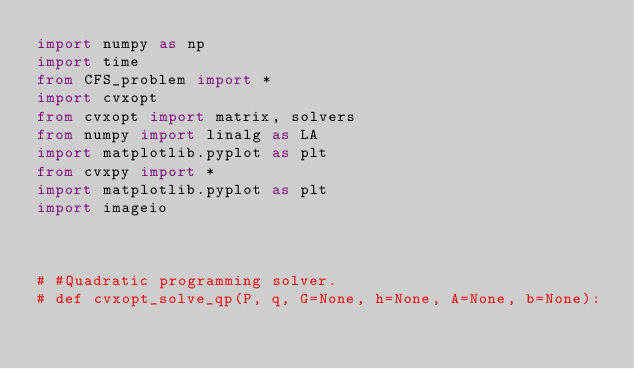<code> <loc_0><loc_0><loc_500><loc_500><_Python_>import numpy as np
import time
from CFS_problem import *
import cvxopt
from cvxopt import matrix, solvers
from numpy import linalg as LA
import matplotlib.pyplot as plt
from cvxpy import *
import matplotlib.pyplot as plt
import imageio



# #Quadratic programming solver.
# def cvxopt_solve_qp(P, q, G=None, h=None, A=None, b=None):</code> 